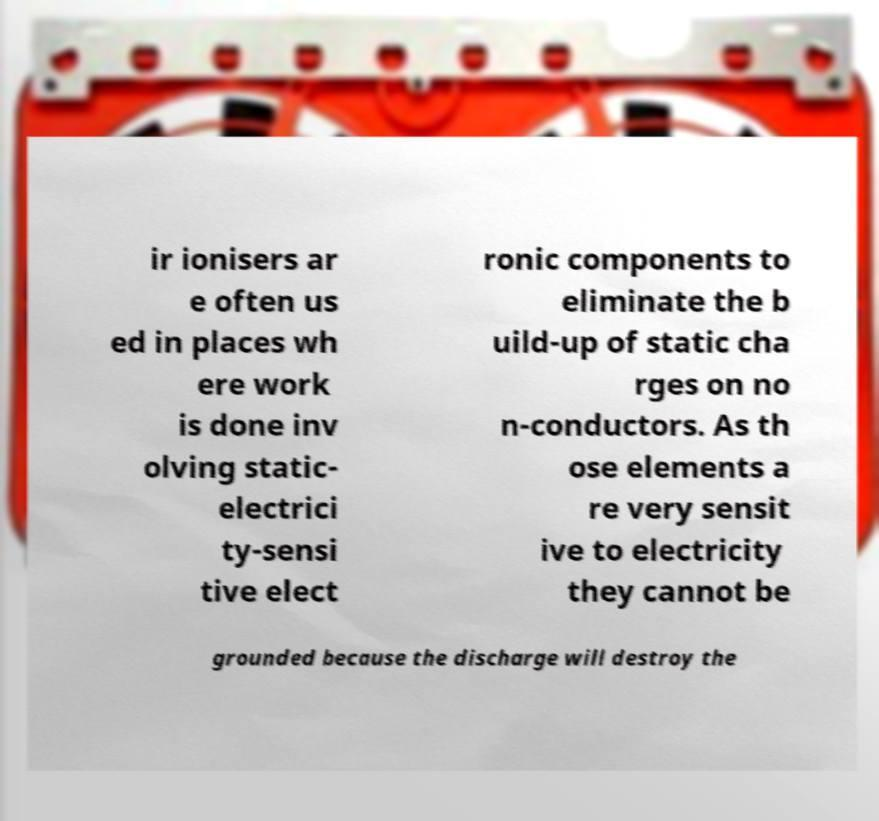There's text embedded in this image that I need extracted. Can you transcribe it verbatim? ir ionisers ar e often us ed in places wh ere work is done inv olving static- electrici ty-sensi tive elect ronic components to eliminate the b uild-up of static cha rges on no n-conductors. As th ose elements a re very sensit ive to electricity they cannot be grounded because the discharge will destroy the 